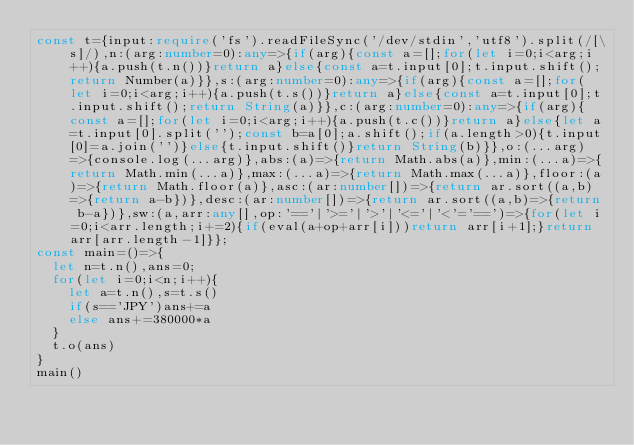<code> <loc_0><loc_0><loc_500><loc_500><_TypeScript_>const t={input:require('fs').readFileSync('/dev/stdin','utf8').split(/[\s]/),n:(arg:number=0):any=>{if(arg){const a=[];for(let i=0;i<arg;i++){a.push(t.n())}return a}else{const a=t.input[0];t.input.shift();return Number(a)}},s:(arg:number=0):any=>{if(arg){const a=[];for(let i=0;i<arg;i++){a.push(t.s())}return a}else{const a=t.input[0];t.input.shift();return String(a)}},c:(arg:number=0):any=>{if(arg){const a=[];for(let i=0;i<arg;i++){a.push(t.c())}return a}else{let a=t.input[0].split('');const b=a[0];a.shift();if(a.length>0){t.input[0]=a.join('')}else{t.input.shift()}return String(b)}},o:(...arg)=>{console.log(...arg)},abs:(a)=>{return Math.abs(a)},min:(...a)=>{return Math.min(...a)},max:(...a)=>{return Math.max(...a)},floor:(a)=>{return Math.floor(a)},asc:(ar:number[])=>{return ar.sort((a,b)=>{return a-b})},desc:(ar:number[])=>{return ar.sort((a,b)=>{return b-a})},sw:(a,arr:any[],op:'=='|'>='|'>'|'<='|'<'='==')=>{for(let i=0;i<arr.length;i+=2){if(eval(a+op+arr[i]))return arr[i+1];}return arr[arr.length-1]}};
const main=()=>{
  let n=t.n(),ans=0;
  for(let i=0;i<n;i++){
    let a=t.n(),s=t.s()
    if(s=='JPY')ans+=a
    else ans+=380000*a
  }
  t.o(ans)
}
main()</code> 